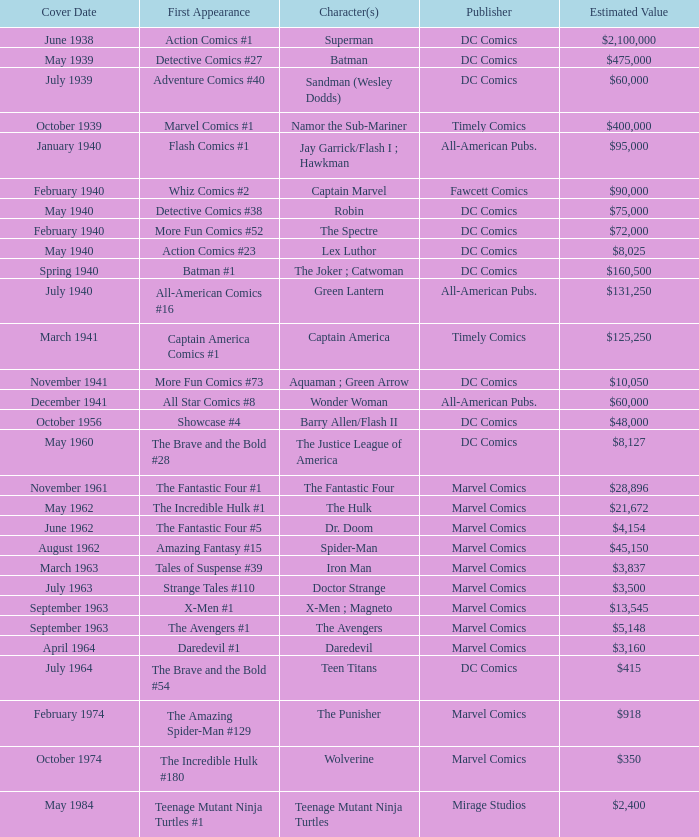Who publishes Wolverine? Marvel Comics. 